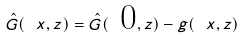Convert formula to latex. <formula><loc_0><loc_0><loc_500><loc_500>\hat { G } ( \ x , z ) = \hat { G } ( \text { 0} , z ) - g ( \ x , z )</formula> 